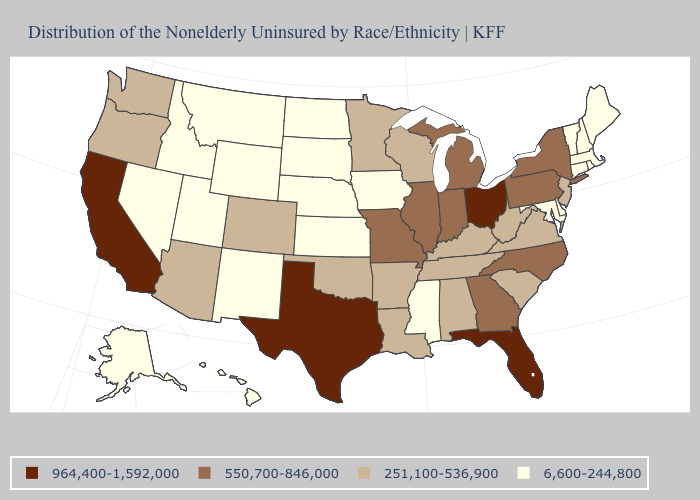What is the lowest value in the USA?
Give a very brief answer. 6,600-244,800. Name the states that have a value in the range 251,100-536,900?
Give a very brief answer. Alabama, Arizona, Arkansas, Colorado, Kentucky, Louisiana, Minnesota, New Jersey, Oklahoma, Oregon, South Carolina, Tennessee, Virginia, Washington, West Virginia, Wisconsin. What is the value of Minnesota?
Give a very brief answer. 251,100-536,900. What is the value of Nebraska?
Concise answer only. 6,600-244,800. Name the states that have a value in the range 251,100-536,900?
Short answer required. Alabama, Arizona, Arkansas, Colorado, Kentucky, Louisiana, Minnesota, New Jersey, Oklahoma, Oregon, South Carolina, Tennessee, Virginia, Washington, West Virginia, Wisconsin. Does New York have the highest value in the Northeast?
Be succinct. Yes. Name the states that have a value in the range 6,600-244,800?
Concise answer only. Alaska, Connecticut, Delaware, Hawaii, Idaho, Iowa, Kansas, Maine, Maryland, Massachusetts, Mississippi, Montana, Nebraska, Nevada, New Hampshire, New Mexico, North Dakota, Rhode Island, South Dakota, Utah, Vermont, Wyoming. Does Kentucky have the highest value in the South?
Write a very short answer. No. Does Idaho have the lowest value in the West?
Quick response, please. Yes. Name the states that have a value in the range 550,700-846,000?
Answer briefly. Georgia, Illinois, Indiana, Michigan, Missouri, New York, North Carolina, Pennsylvania. Which states have the lowest value in the USA?
Quick response, please. Alaska, Connecticut, Delaware, Hawaii, Idaho, Iowa, Kansas, Maine, Maryland, Massachusetts, Mississippi, Montana, Nebraska, Nevada, New Hampshire, New Mexico, North Dakota, Rhode Island, South Dakota, Utah, Vermont, Wyoming. Name the states that have a value in the range 6,600-244,800?
Write a very short answer. Alaska, Connecticut, Delaware, Hawaii, Idaho, Iowa, Kansas, Maine, Maryland, Massachusetts, Mississippi, Montana, Nebraska, Nevada, New Hampshire, New Mexico, North Dakota, Rhode Island, South Dakota, Utah, Vermont, Wyoming. Does Oklahoma have a higher value than Vermont?
Be succinct. Yes. What is the value of New Jersey?
Answer briefly. 251,100-536,900. Name the states that have a value in the range 550,700-846,000?
Keep it brief. Georgia, Illinois, Indiana, Michigan, Missouri, New York, North Carolina, Pennsylvania. 